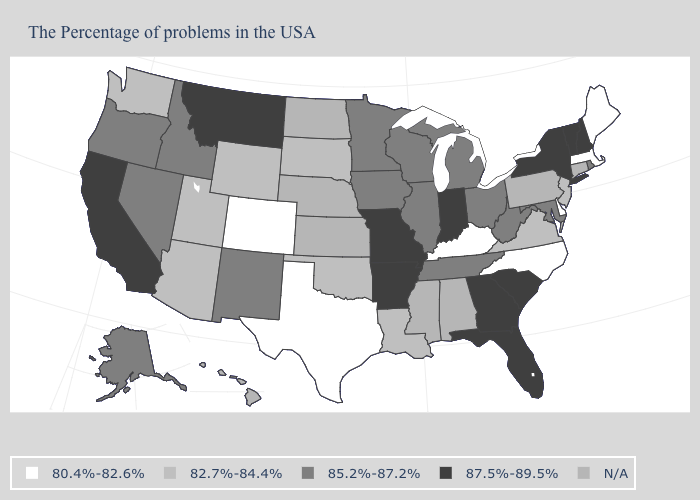How many symbols are there in the legend?
Quick response, please. 5. What is the value of Alabama?
Give a very brief answer. N/A. What is the value of New York?
Quick response, please. 87.5%-89.5%. What is the value of New Hampshire?
Be succinct. 87.5%-89.5%. What is the highest value in the USA?
Write a very short answer. 87.5%-89.5%. What is the lowest value in the West?
Short answer required. 80.4%-82.6%. What is the highest value in the USA?
Short answer required. 87.5%-89.5%. What is the value of South Dakota?
Keep it brief. 82.7%-84.4%. Which states have the lowest value in the West?
Keep it brief. Colorado. Is the legend a continuous bar?
Keep it brief. No. What is the value of Oregon?
Quick response, please. 85.2%-87.2%. What is the value of North Carolina?
Write a very short answer. 80.4%-82.6%. Is the legend a continuous bar?
Answer briefly. No. Does Georgia have the highest value in the South?
Quick response, please. Yes. 